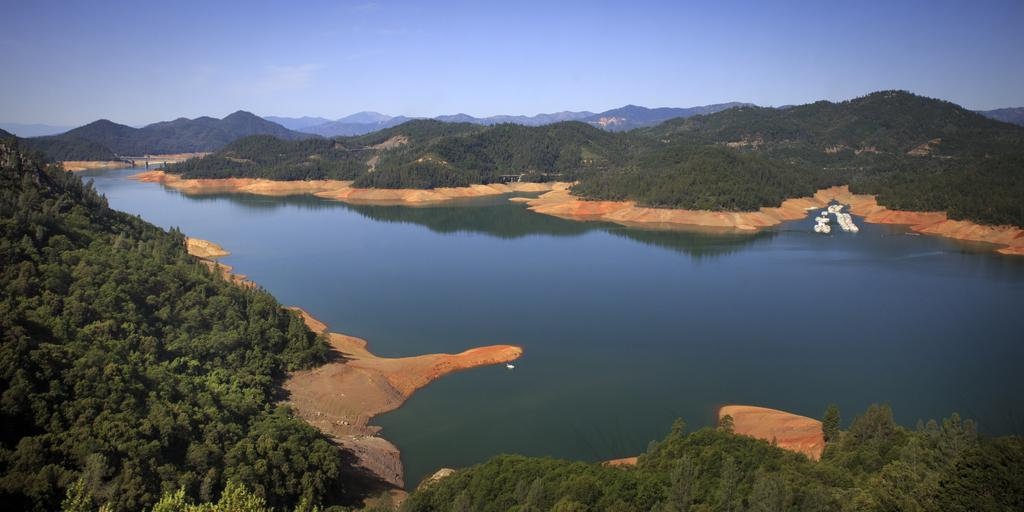What type of natural feature is the main subject of the image? There is a lake in the image. What can be seen in the background of the image? There are many trees and mountains in the background of the image. What is visible at the top of the image? The sky is visible at the top of the image. What can be observed in the sky? Clouds are present in the sky. Where is the sofa located in the image? There is no sofa present in the image. How many women are riding the horses in the image? There are no horses or women present in the image. 